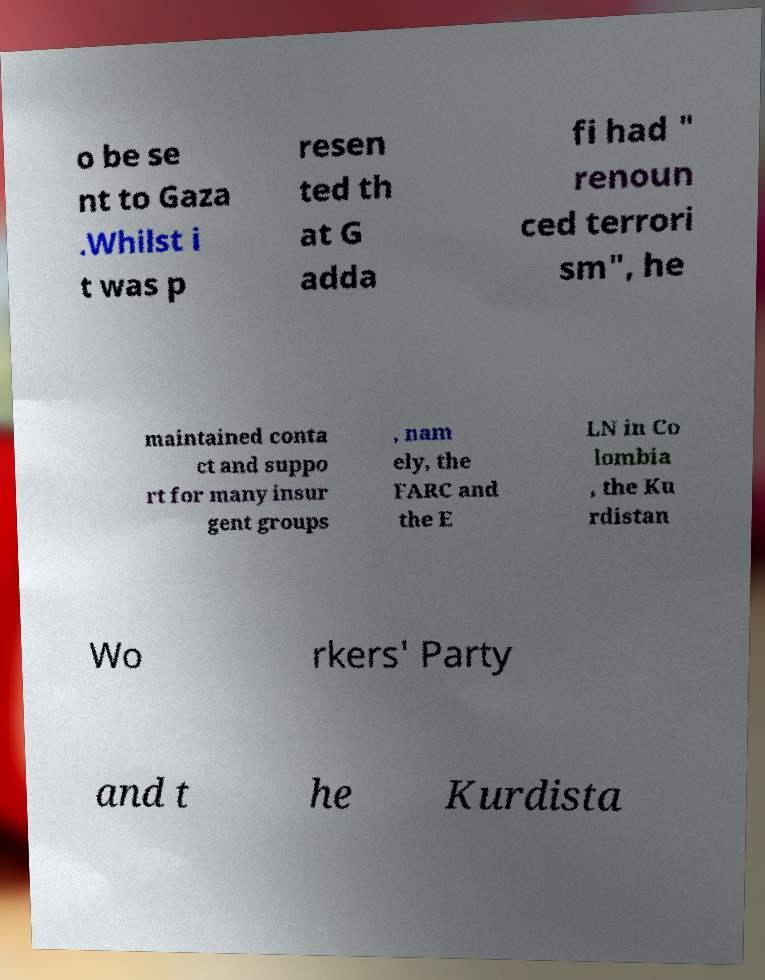Can you accurately transcribe the text from the provided image for me? o be se nt to Gaza .Whilst i t was p resen ted th at G adda fi had " renoun ced terrori sm", he maintained conta ct and suppo rt for many insur gent groups , nam ely, the FARC and the E LN in Co lombia , the Ku rdistan Wo rkers' Party and t he Kurdista 